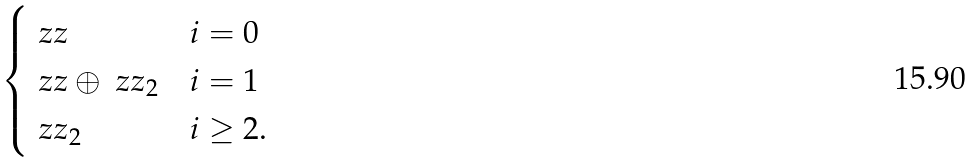<formula> <loc_0><loc_0><loc_500><loc_500>\begin{cases} \ z z & i = 0 \\ \ z z \oplus \ z z _ { 2 } & i = 1 \\ \ z z _ { 2 } & i \geq 2 . \end{cases}</formula> 